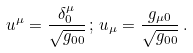<formula> <loc_0><loc_0><loc_500><loc_500>u ^ { \mu } = \frac { \delta ^ { \mu } _ { 0 } } { \sqrt { g _ { 0 0 } } } \, ; \, u _ { \mu } = \frac { g _ { \mu 0 } } { \sqrt { g _ { 0 0 } } } \, .</formula> 